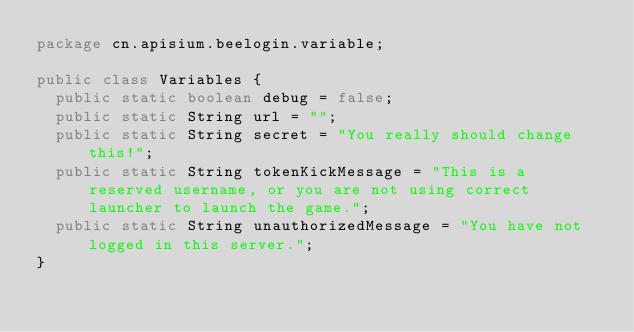Convert code to text. <code><loc_0><loc_0><loc_500><loc_500><_Java_>package cn.apisium.beelogin.variable;

public class Variables {
	public static boolean debug = false;
	public static String url = "";
	public static String secret = "You really should change this!";
	public static String tokenKickMessage = "This is a reserved username, or you are not using correct launcher to launch the game.";
	public static String unauthorizedMessage = "You have not logged in this server.";
}
</code> 